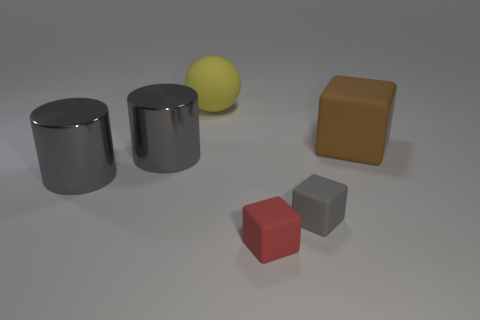What is the big ball made of?
Your response must be concise. Rubber. Is the number of small red matte blocks on the right side of the large brown thing greater than the number of small gray things?
Make the answer very short. No. Are any big brown things visible?
Your answer should be very brief. Yes. What number of other things are there of the same shape as the yellow rubber object?
Your response must be concise. 0. There is a tiny matte block that is to the right of the tiny red thing; does it have the same color as the large rubber object that is left of the red object?
Ensure brevity in your answer.  No. There is a gray object that is to the right of the tiny red matte thing that is in front of the large matte thing in front of the ball; what is its size?
Provide a succinct answer. Small. There is a matte object that is behind the gray rubber cube and right of the small red block; what is its shape?
Give a very brief answer. Cube. Is the number of large gray metallic cylinders behind the red thing the same as the number of gray things behind the large brown matte object?
Your answer should be very brief. No. Is there a big gray cylinder made of the same material as the tiny gray object?
Your answer should be very brief. No. Are the gray thing that is on the right side of the yellow ball and the yellow thing made of the same material?
Offer a very short reply. Yes. 